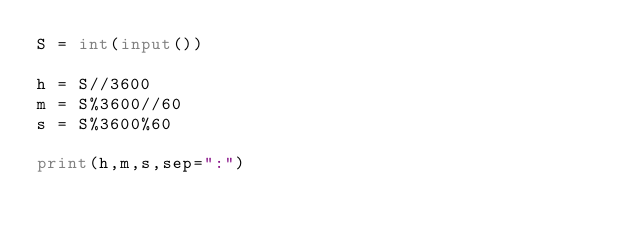Convert code to text. <code><loc_0><loc_0><loc_500><loc_500><_Python_>S = int(input())

h = S//3600
m = S%3600//60
s = S%3600%60

print(h,m,s,sep=":")</code> 